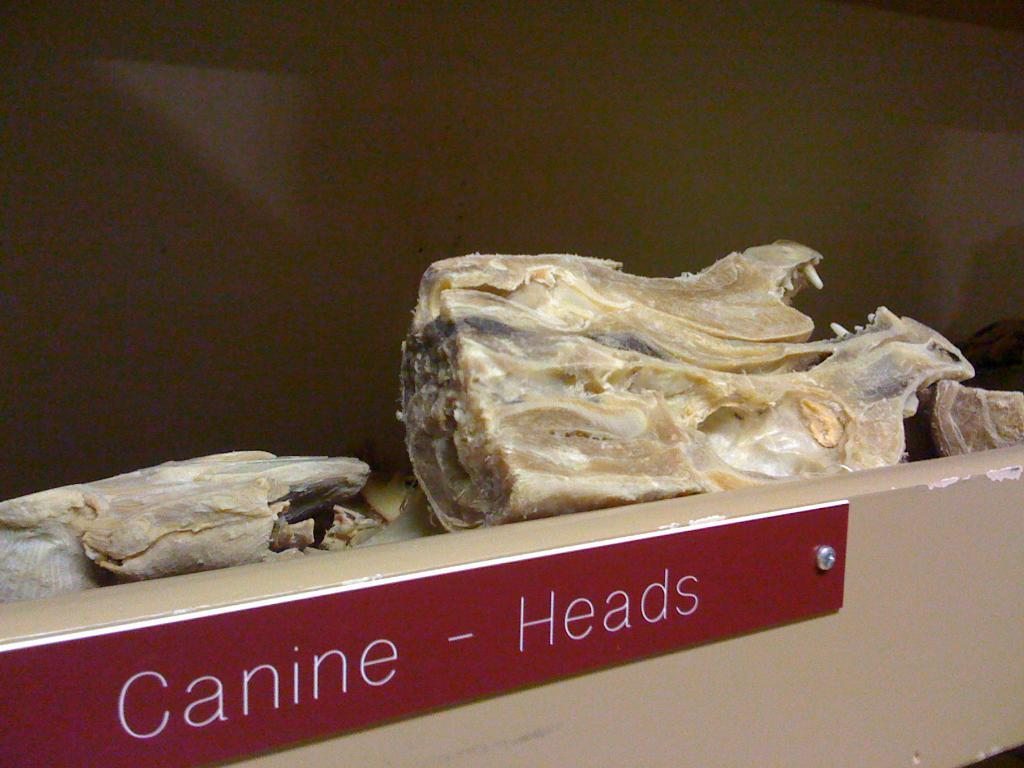What objects are present in the image? There are bones in the image, and they are kept in a box. What can be found on the box? There is a nameplate on the box. What is the color of the nameplate? The nameplate is red in color. How would you describe the background of the image? The background of the image is blurred. What type of juice can be seen in the image? There is no juice present in the image. How does the acoustics of the room affect the sound of the bones in the image? The image does not provide any information about the acoustics of the room, so we cannot determine how it affects the sound of the bones. What kind of marble is visible in the image? There is no marble present in the image. 